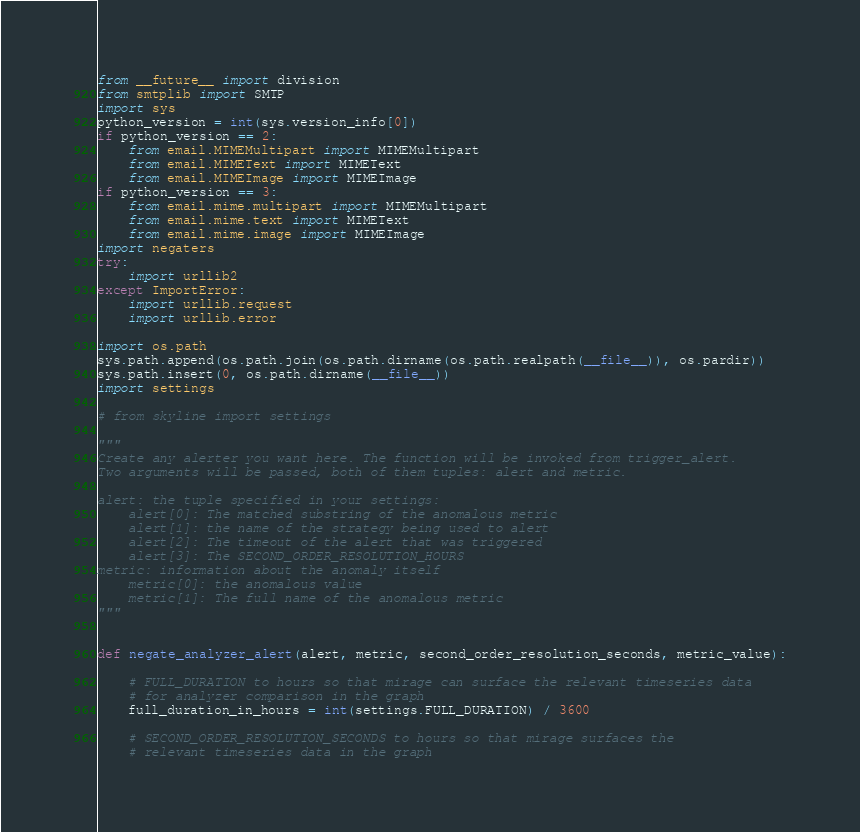<code> <loc_0><loc_0><loc_500><loc_500><_Python_>from __future__ import division
from smtplib import SMTP
import sys
python_version = int(sys.version_info[0])
if python_version == 2:
    from email.MIMEMultipart import MIMEMultipart
    from email.MIMEText import MIMEText
    from email.MIMEImage import MIMEImage
if python_version == 3:
    from email.mime.multipart import MIMEMultipart
    from email.mime.text import MIMEText
    from email.mime.image import MIMEImage
import negaters
try:
    import urllib2
except ImportError:
    import urllib.request
    import urllib.error

import os.path
sys.path.append(os.path.join(os.path.dirname(os.path.realpath(__file__)), os.pardir))
sys.path.insert(0, os.path.dirname(__file__))
import settings

# from skyline import settings

"""
Create any alerter you want here. The function will be invoked from trigger_alert.
Two arguments will be passed, both of them tuples: alert and metric.

alert: the tuple specified in your settings:
    alert[0]: The matched substring of the anomalous metric
    alert[1]: the name of the strategy being used to alert
    alert[2]: The timeout of the alert that was triggered
    alert[3]: The SECOND_ORDER_RESOLUTION_HOURS
metric: information about the anomaly itself
    metric[0]: the anomalous value
    metric[1]: The full name of the anomalous metric
"""


def negate_analyzer_alert(alert, metric, second_order_resolution_seconds, metric_value):

    # FULL_DURATION to hours so that mirage can surface the relevant timeseries data
    # for analyzer comparison in the graph
    full_duration_in_hours = int(settings.FULL_DURATION) / 3600

    # SECOND_ORDER_RESOLUTION_SECONDS to hours so that mirage surfaces the
    # relevant timeseries data in the graph</code> 